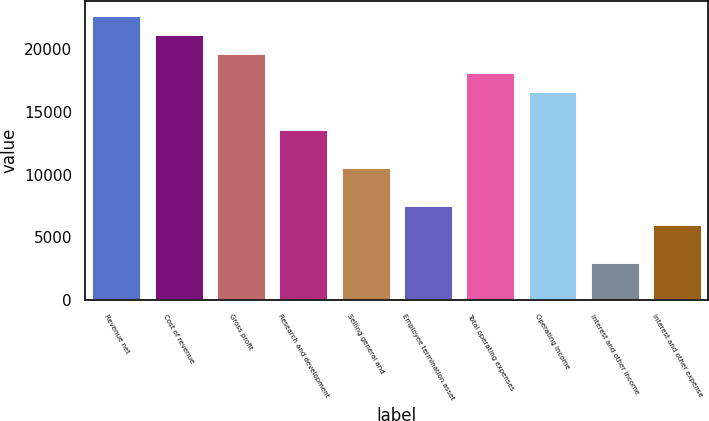Convert chart. <chart><loc_0><loc_0><loc_500><loc_500><bar_chart><fcel>Revenue net<fcel>Cost of revenue<fcel>Gross profit<fcel>Research and development<fcel>Selling general and<fcel>Employee termination asset<fcel>Total operating expenses<fcel>Operating income<fcel>Interest and other income<fcel>Interest and other expense<nl><fcel>22691.6<fcel>21179.3<fcel>19667<fcel>13617.6<fcel>10593<fcel>7568.33<fcel>18154.6<fcel>16642.3<fcel>3031.34<fcel>6056<nl></chart> 